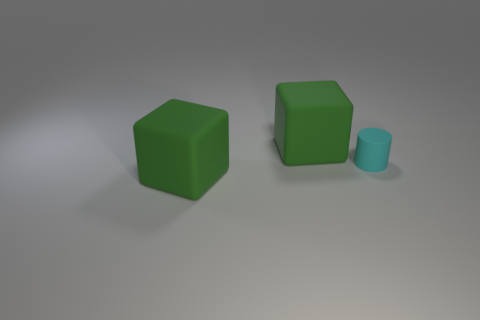What number of gray things are either large things or tiny matte objects?
Give a very brief answer. 0. Is the number of big green things greater than the number of cyan rubber objects?
Offer a very short reply. Yes. Do the green matte object in front of the tiny cyan rubber cylinder and the object behind the cylinder have the same size?
Offer a terse response. Yes. There is a large block behind the large green rubber cube that is in front of the big matte cube that is behind the cyan object; what is its color?
Your response must be concise. Green. Is the number of big rubber cubes behind the tiny matte cylinder greater than the number of small matte things?
Offer a terse response. No. What number of matte objects are tiny cyan cylinders or big blue cylinders?
Your answer should be compact. 1. Are there any rubber blocks in front of the big matte cube in front of the tiny matte object?
Offer a very short reply. No. There is a cyan cylinder; how many green objects are in front of it?
Make the answer very short. 1. How many matte objects are there?
Provide a succinct answer. 3. There is a large green matte object that is in front of the tiny cylinder; does it have the same shape as the cyan thing?
Provide a short and direct response. No. 